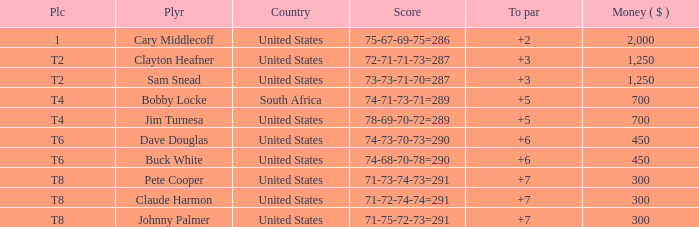What is the Johnny Palmer with a To larger than 6 Money sum? 300.0. 